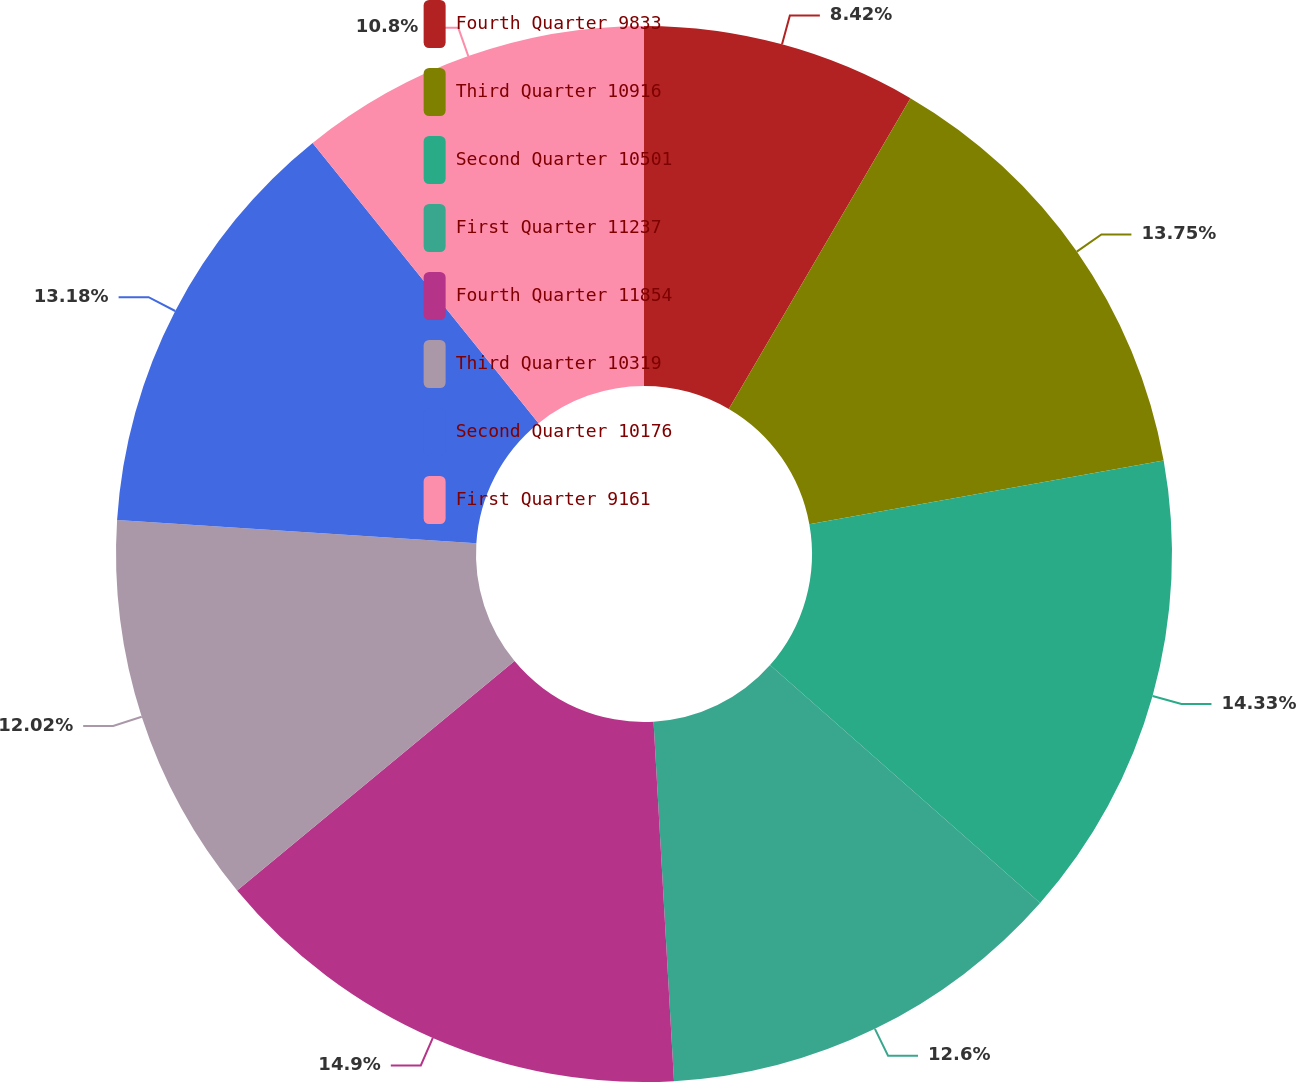Convert chart. <chart><loc_0><loc_0><loc_500><loc_500><pie_chart><fcel>Fourth Quarter 9833<fcel>Third Quarter 10916<fcel>Second Quarter 10501<fcel>First Quarter 11237<fcel>Fourth Quarter 11854<fcel>Third Quarter 10319<fcel>Second Quarter 10176<fcel>First Quarter 9161<nl><fcel>8.42%<fcel>13.75%<fcel>14.33%<fcel>12.6%<fcel>14.91%<fcel>12.02%<fcel>13.18%<fcel>10.8%<nl></chart> 